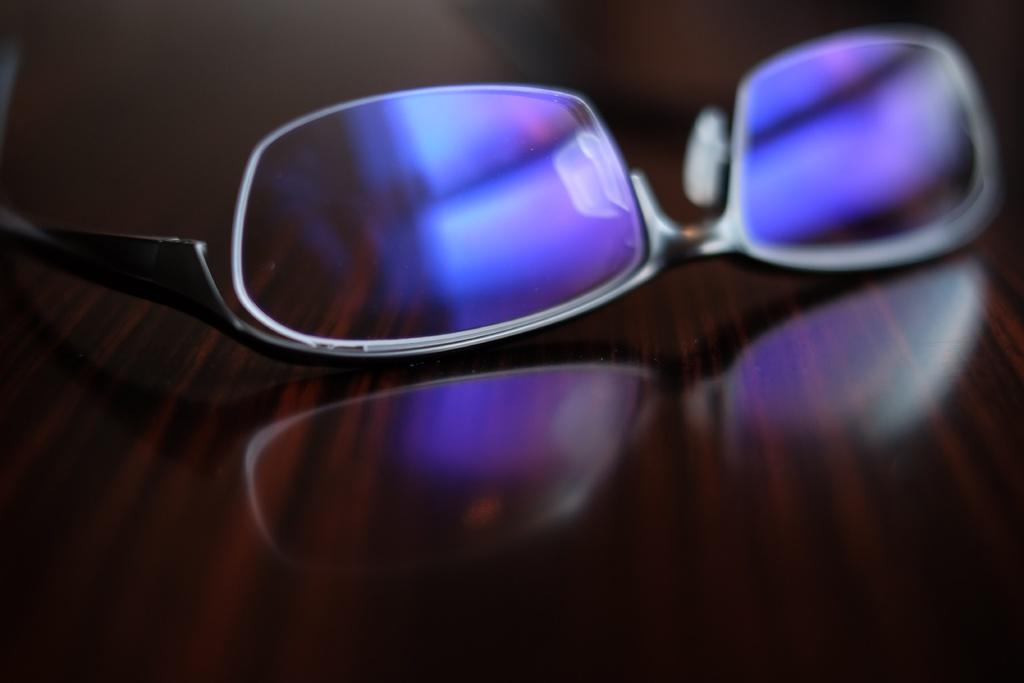What can be seen in the image that is used for vision correction? There are spectacles in the image. Where are the spectacles placed in the image? The spectacles are on an object. What is the name of the object on which the spectacles are placed? The object is described as a table. What type of toy is visible in the image? There is no toy present in the image. What part of the table is the spectacles placed on? The provided facts do not specify which part of the table the spectacles are placed on. 